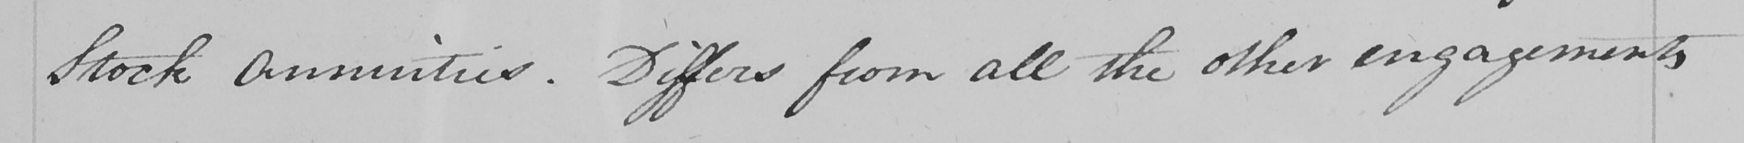Can you read and transcribe this handwriting? Stock Annuities . Differs from all the other engagements 